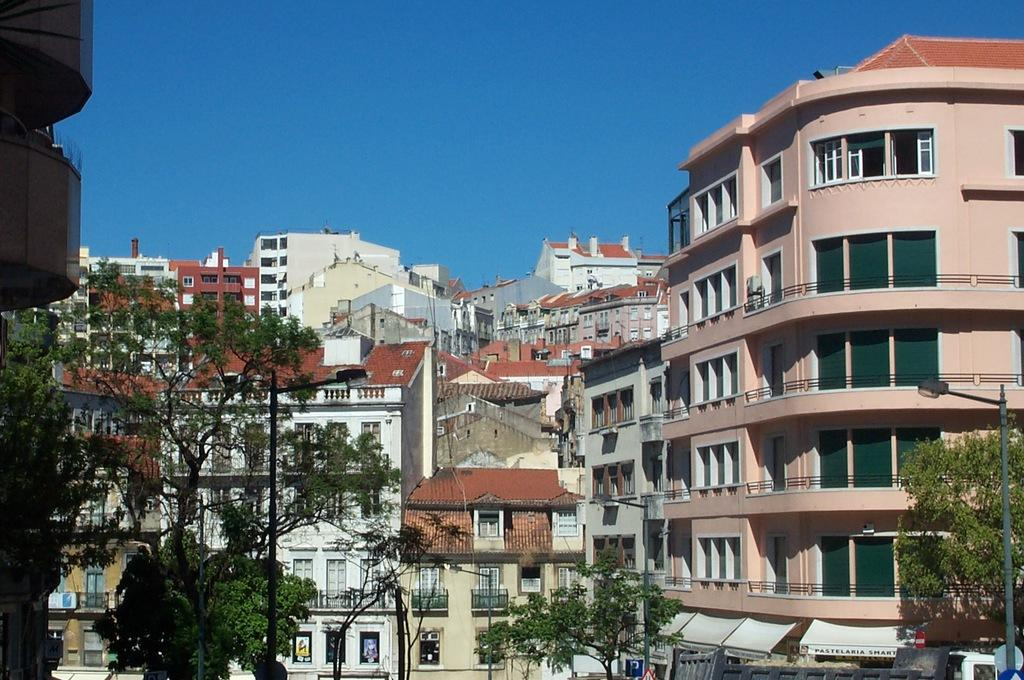What type of structures can be seen in the image? There are many buildings in the image. What other natural or man-made elements can be seen in the image? Trees, electric poles, street lights, and windows are visible in the image. What type of temporary shelter is present at the bottom of the image? There are tents at the bottom of the image. What part of the natural environment is visible in the image? The sky is visible at the top of the image. Can you describe the beetle that is sitting on top of the street light in the image? There is no beetle present on top of the street light in the image. What type of flame can be seen coming from the windows in the image? There are no flames visible in the windows in the image. 